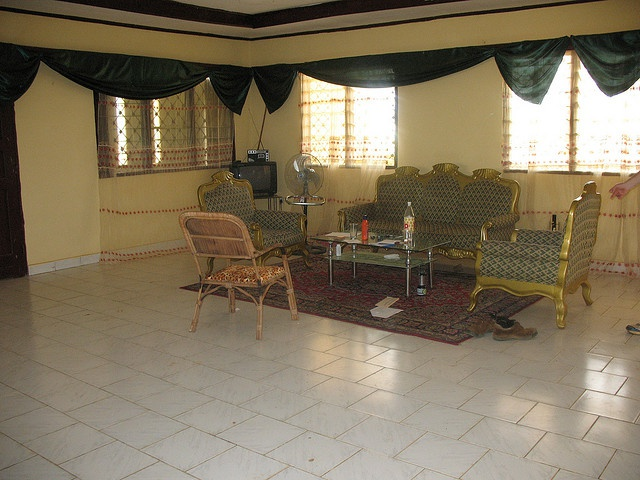Describe the objects in this image and their specific colors. I can see couch in black, olive, and gray tones, chair in black, olive, and gray tones, chair in black, maroon, gray, and brown tones, chair in black, olive, and gray tones, and dining table in black, darkgreen, and gray tones in this image. 